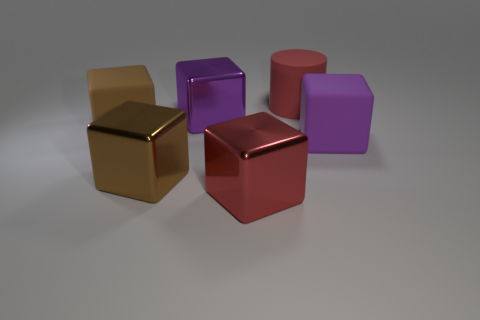There is a big rubber cube left of the metallic thing that is to the right of the big purple metal block; what color is it?
Offer a terse response. Brown. How many big blocks are both behind the red shiny object and left of the red rubber cylinder?
Make the answer very short. 3. How many other big red rubber objects have the same shape as the red matte object?
Offer a very short reply. 0. Do the red block and the cylinder have the same material?
Ensure brevity in your answer.  No. The matte object that is to the left of the big purple object that is behind the brown rubber thing is what shape?
Offer a very short reply. Cube. There is a matte cube in front of the brown matte cube; what number of big red metallic objects are on the left side of it?
Keep it short and to the point. 1. There is a large thing that is left of the big purple metal block and on the right side of the large brown rubber object; what material is it?
Your answer should be very brief. Metal. The red metallic thing that is the same size as the purple metal object is what shape?
Make the answer very short. Cube. There is a large rubber block that is to the right of the large metallic block that is behind the brown shiny block that is on the right side of the big brown matte thing; what is its color?
Give a very brief answer. Purple. What number of things are either red objects in front of the large brown metallic object or metallic objects?
Provide a short and direct response. 3. 